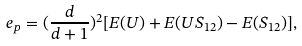<formula> <loc_0><loc_0><loc_500><loc_500>e _ { p } = ( \frac { d } { d + 1 } ) ^ { 2 } [ E ( U ) + E ( U S _ { 1 2 } ) - E ( S _ { 1 2 } ) ] ,</formula> 